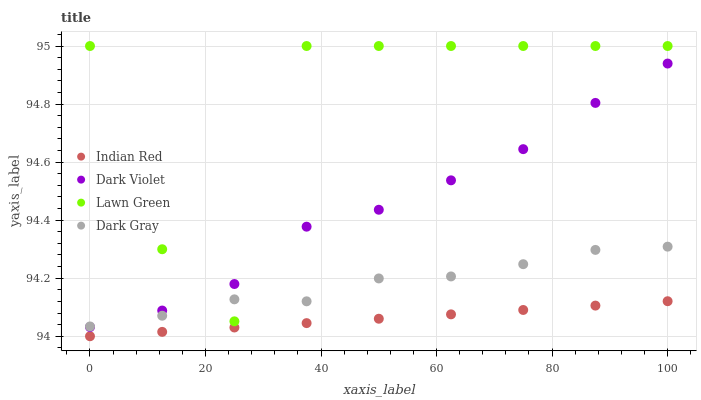Does Indian Red have the minimum area under the curve?
Answer yes or no. Yes. Does Lawn Green have the maximum area under the curve?
Answer yes or no. Yes. Does Dark Violet have the minimum area under the curve?
Answer yes or no. No. Does Dark Violet have the maximum area under the curve?
Answer yes or no. No. Is Indian Red the smoothest?
Answer yes or no. Yes. Is Lawn Green the roughest?
Answer yes or no. Yes. Is Dark Violet the smoothest?
Answer yes or no. No. Is Dark Violet the roughest?
Answer yes or no. No. Does Indian Red have the lowest value?
Answer yes or no. Yes. Does Dark Violet have the lowest value?
Answer yes or no. No. Does Lawn Green have the highest value?
Answer yes or no. Yes. Does Dark Violet have the highest value?
Answer yes or no. No. Is Indian Red less than Dark Gray?
Answer yes or no. Yes. Is Dark Gray greater than Indian Red?
Answer yes or no. Yes. Does Dark Gray intersect Dark Violet?
Answer yes or no. Yes. Is Dark Gray less than Dark Violet?
Answer yes or no. No. Is Dark Gray greater than Dark Violet?
Answer yes or no. No. Does Indian Red intersect Dark Gray?
Answer yes or no. No. 